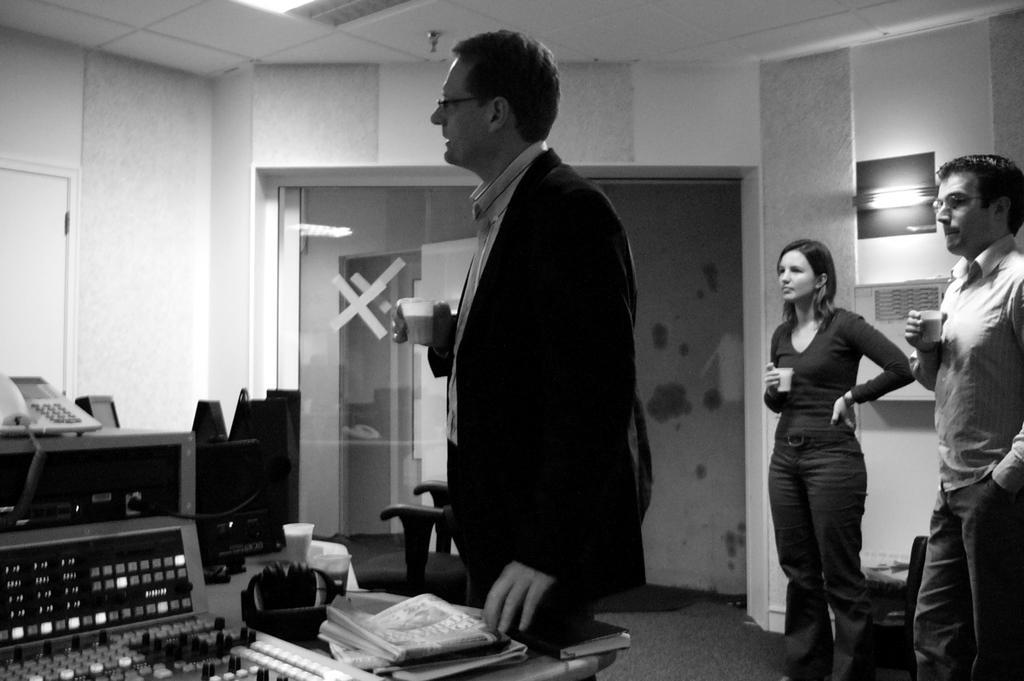How would you summarize this image in a sentence or two? This is a black and white picture. In this picture, we see three people are standing. Three of them are holding a cup containing cup or tea in their hands. At the bottom of the picture, we see a table on which books are placed. Beside that, we see a music recorder. Behind that, we see a table on which landline phone is placed. Behind that, there are chairs. In the background, we see a wall and a glass door. 